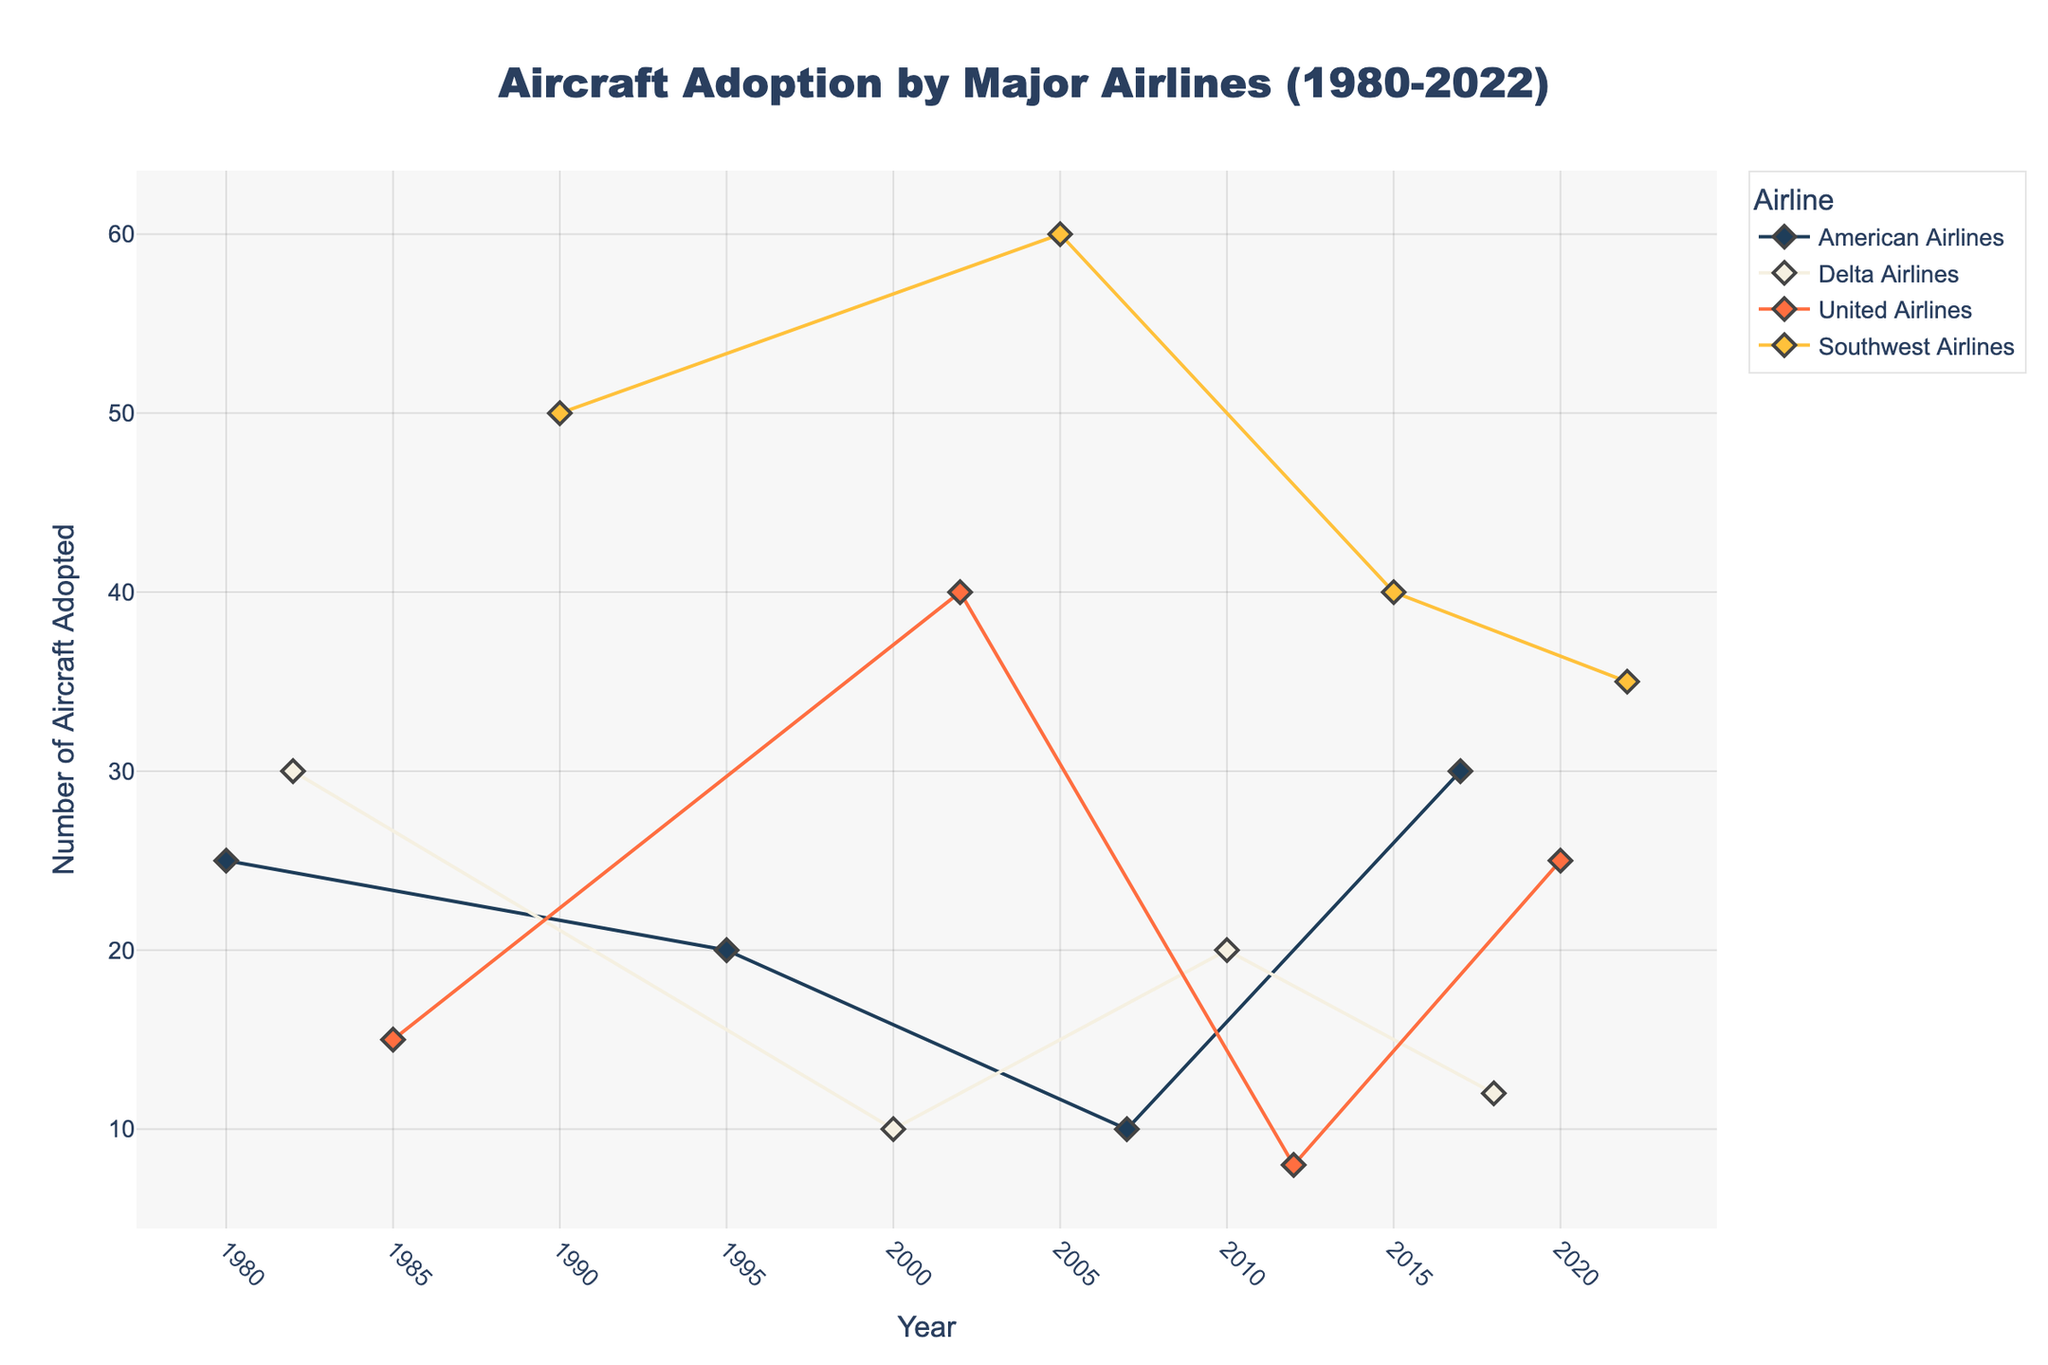what is the title of the plot? The title of the plot is usually located at the top of the figure and is often in a larger font compared to other text elements. In this plot, the title is formatted as 'Aircraft Adoption by Major Airlines (1980-2022)'.
Answer: Aircraft Adoption by Major Airlines (1980-2022) What are the labels of the x-axis and y-axis? The x-axis and y-axis labels provide information on what each axis represents. In this plot, the x-axis label is 'Year' and the y-axis label is 'Number of Aircraft Adopted'.
Answer: Year and Number of Aircraft Adopted Which airlines adopted the Boeing 737 MAX models, and in what years? To answer this question, we look for the specific aircraft models 'Boeing 737 MAX 8', 'Boeing 737 MAX 9', and 'Boeing 737 MAX 7' on the plot and check the corresponding airlines and years. 'Boeing 737 MAX 8' was adopted by Southwest Airlines in 2015, 'Boeing 737 MAX 9' by United Airlines in 2020, and 'Boeing 737 MAX 7' by Southwest Airlines in 2022.
Answer: Southwest Airlines in 2015 and 2022, United Airlines in 2020 How many aircraft did American Airlines adopt in 2017? Locate the data point for American Airlines in 2017 and check the y-axis value. In this case, American Airlines adopted 30 aircraft in 2017.
Answer: 30 Which airline had the highest number of aircraft adopted, and in what year? Examine the y-axis values, looking for the highest point on the graph. Southwest Airlines adopted the highest number of aircraft, 60, in the year 2005.
Answer: Southwest Airlines in 2005 What is the total number of aircraft adopted by Delta Airlines from 1980 to 2022? Sum the y-axis values for Delta Airlines across all the years in the plot. The values are 30 (1982), 10 (2000), 20 (2010), and 12 (2018). So, the total is 30 + 10 + 20 + 12 = 72.
Answer: 72 Between 2010 and 2018, which airline had the most consistent number of aircraft adoptions, and what does that consistency indicate? Compare the number of aircraft adopted in multiple years between 2010 and 2018 for each airline. Southwest Airlines shows a steady level of high adoption, with 40 aircraft in 2015. Consistency here indicates more regular updates to their fleet.
Answer: Southwest Airlines, steady updates Which aircraft model did United Airlines adopt in 2002, and how many units were adopted? Find United Airlines in the year 2002 and hover over the data point to see the aircraft model and the number of units. United Airlines adopted the Airbus A319 in 2002 with 40 units.
Answer: Airbus A319, 40 units How did the adoption rate of Boeing 737 models by Southwest Airlines change after 1990? Look for the Boeing 737 models adopted by Southwest Airlines after 1990 and check for changes in number over the years. In 1990, they adopted 50 units of Boeing 737-300, in 2005 they adopted 60 units of Boeing 737-700, and in 2015 they adopted 40 units of Boeing 737 MAX 8, followed by 35 units of Boeing 737 MAX 7 in 2022.
Answer: Decrease then increase in variety 